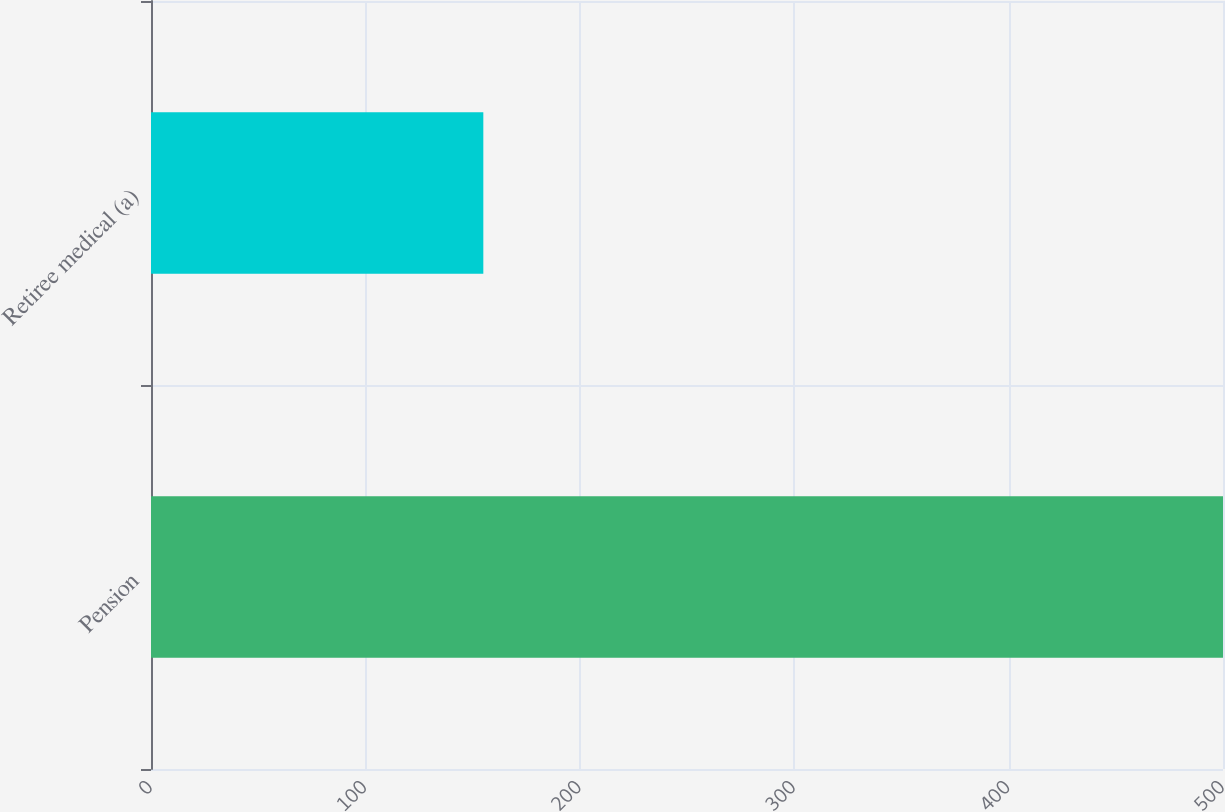Convert chart to OTSL. <chart><loc_0><loc_0><loc_500><loc_500><bar_chart><fcel>Pension<fcel>Retiree medical (a)<nl><fcel>500<fcel>155<nl></chart> 